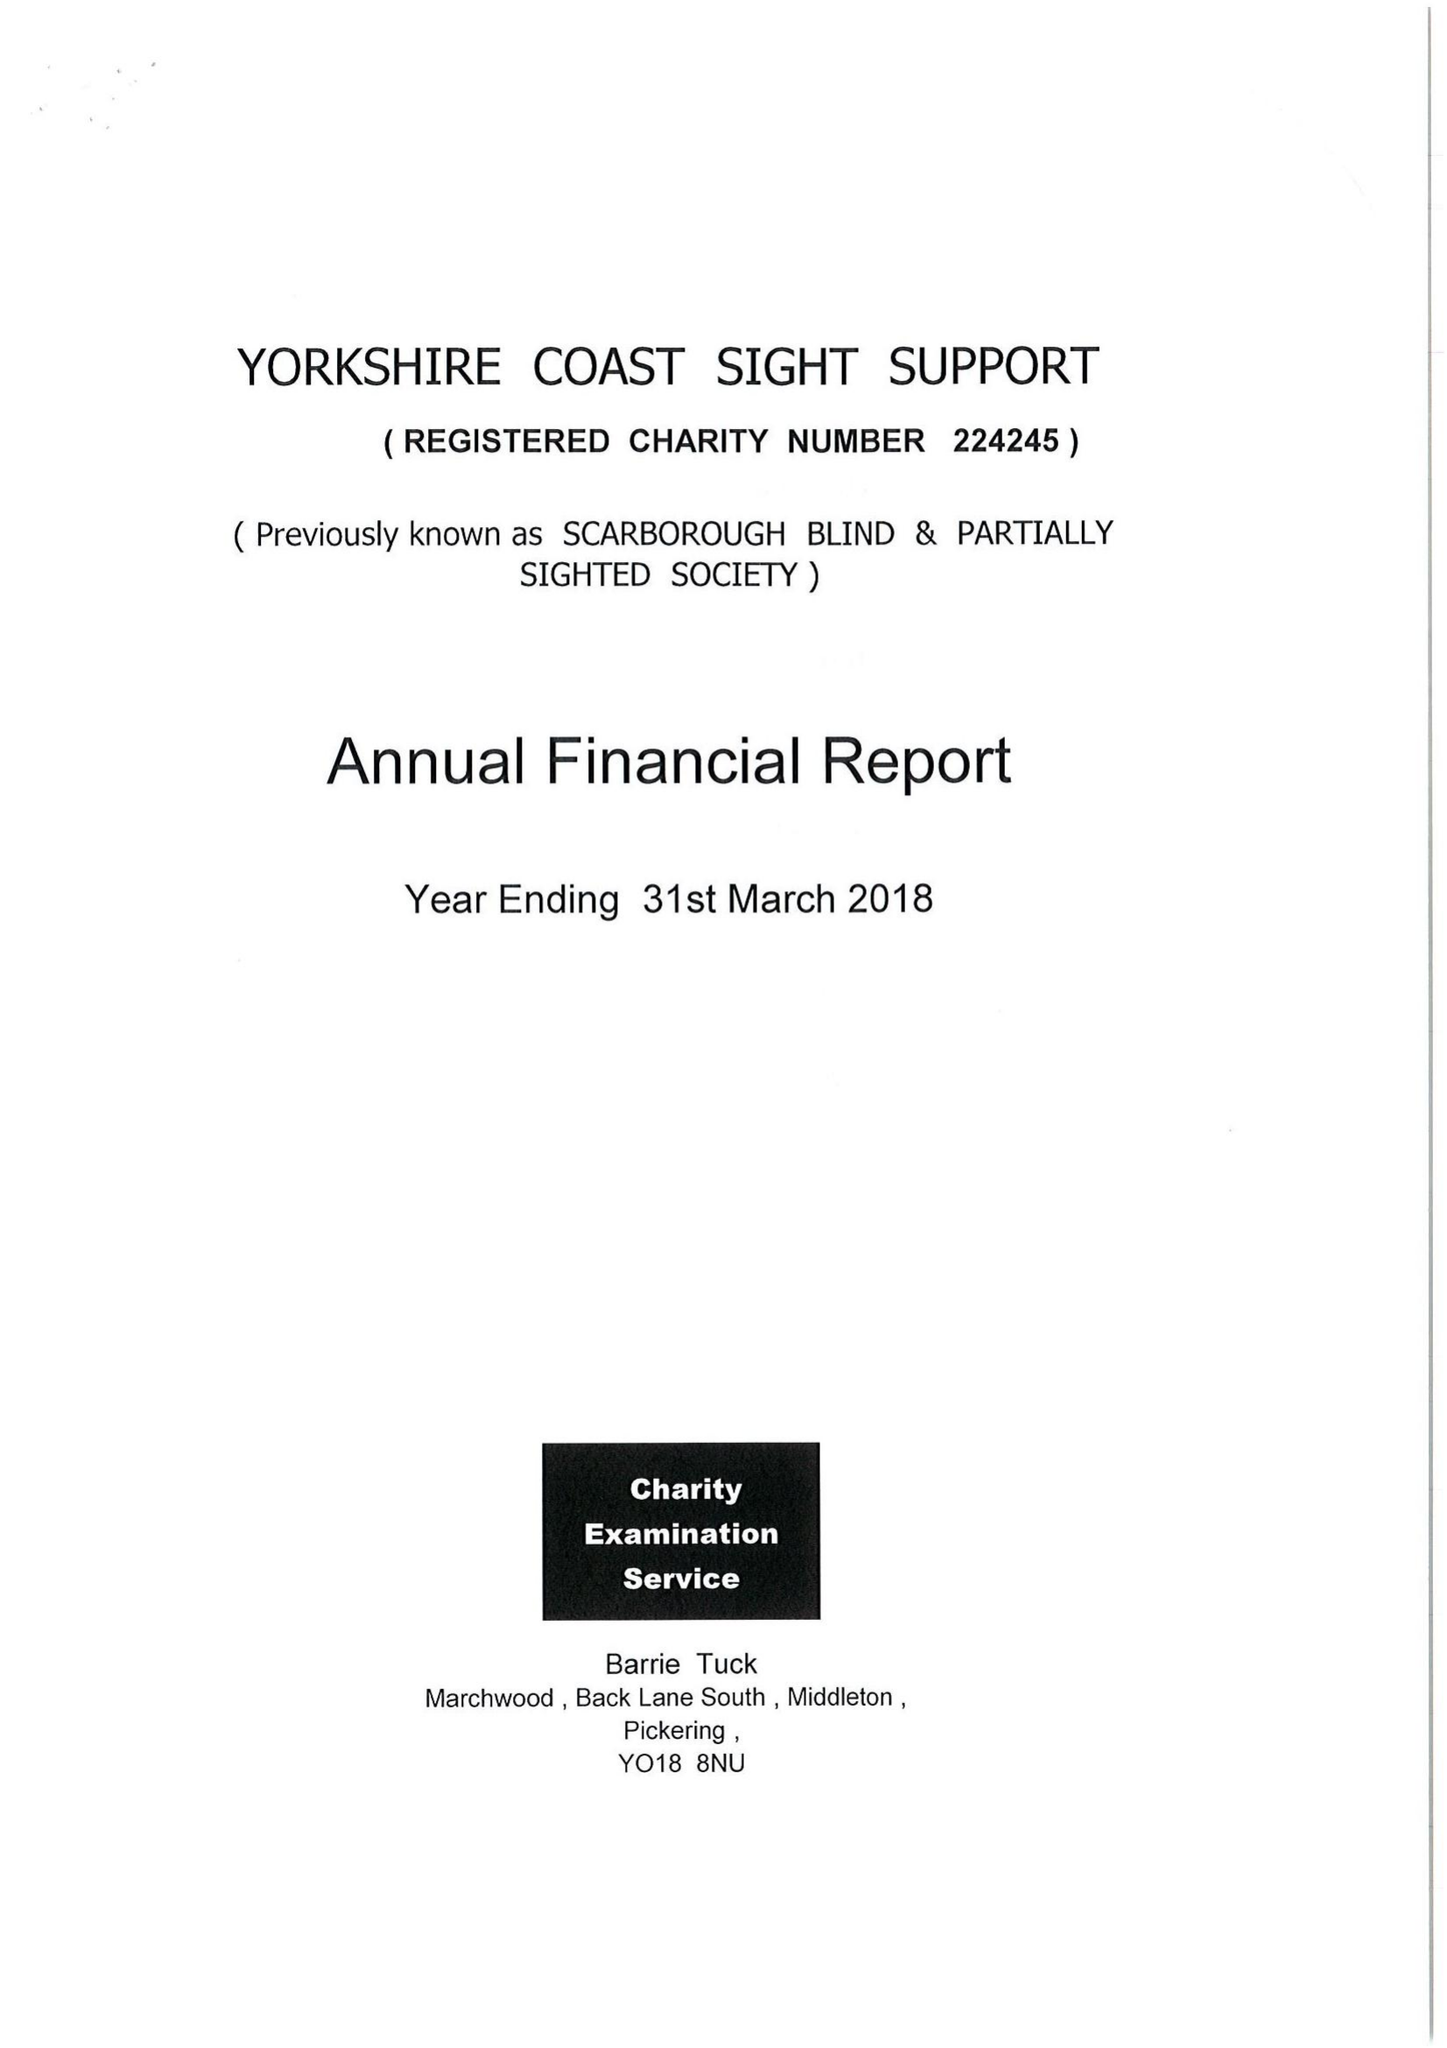What is the value for the address__postcode?
Answer the question using a single word or phrase. YO12 7JH 